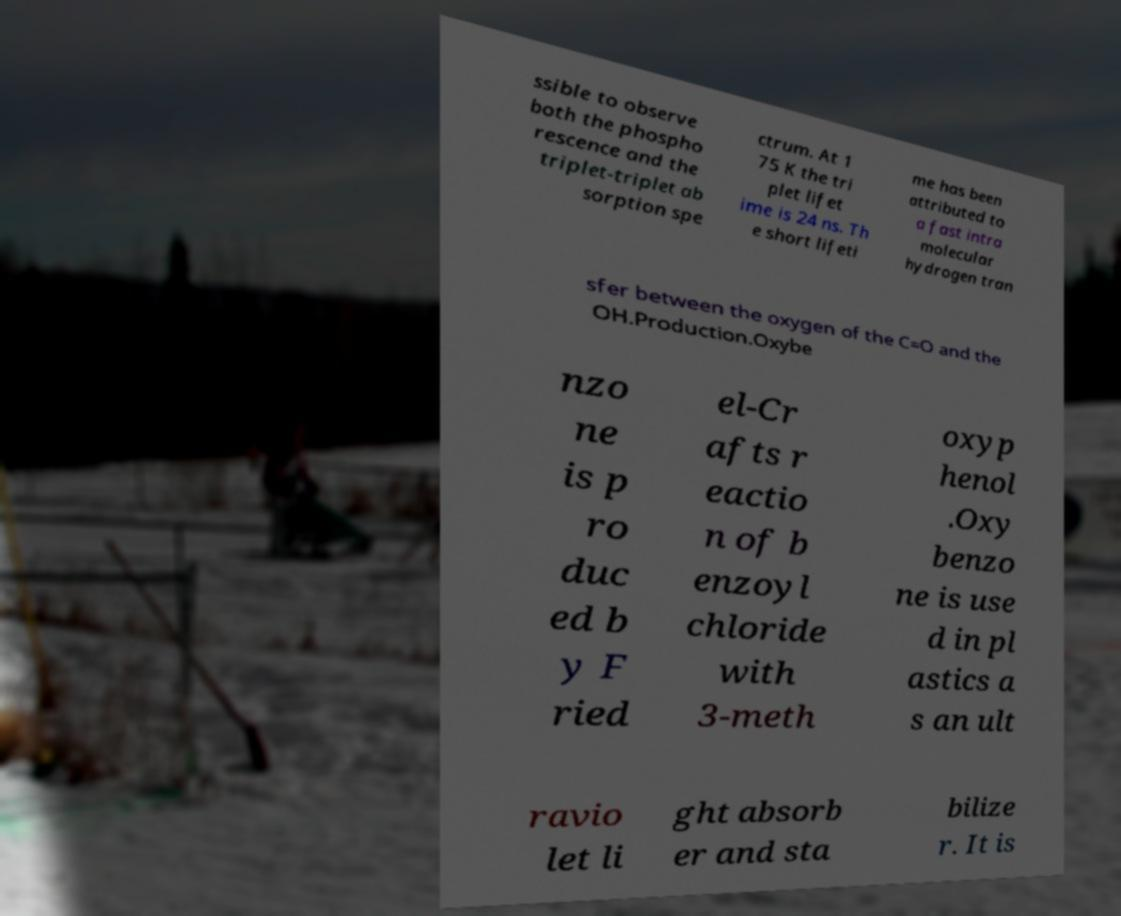Please identify and transcribe the text found in this image. ssible to observe both the phospho rescence and the triplet-triplet ab sorption spe ctrum. At 1 75 K the tri plet lifet ime is 24 ns. Th e short lifeti me has been attributed to a fast intra molecular hydrogen tran sfer between the oxygen of the C=O and the OH.Production.Oxybe nzo ne is p ro duc ed b y F ried el-Cr afts r eactio n of b enzoyl chloride with 3-meth oxyp henol .Oxy benzo ne is use d in pl astics a s an ult ravio let li ght absorb er and sta bilize r. It is 